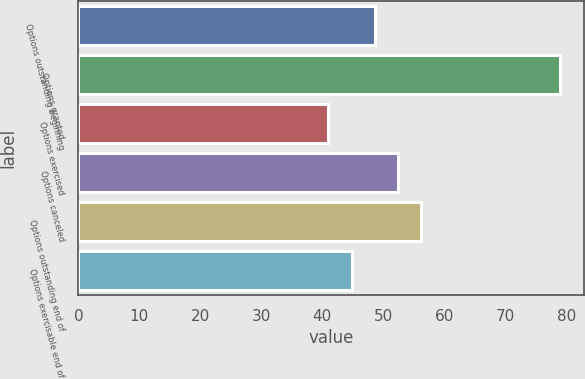Convert chart to OTSL. <chart><loc_0><loc_0><loc_500><loc_500><bar_chart><fcel>Options outstanding beginning<fcel>Options granted<fcel>Options exercised<fcel>Options canceled<fcel>Options outstanding end of<fcel>Options exercisable end of<nl><fcel>48.6<fcel>79<fcel>41<fcel>52.4<fcel>56.2<fcel>44.8<nl></chart> 